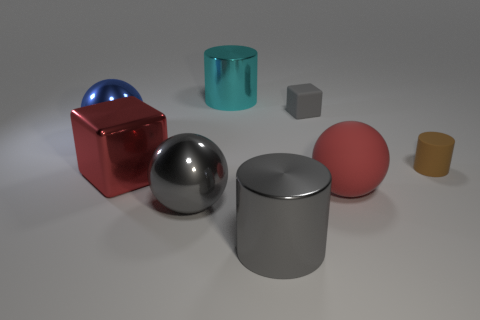There is a object that is the same color as the metal cube; what material is it?
Provide a succinct answer. Rubber. Is the number of big yellow matte balls less than the number of red shiny objects?
Your answer should be very brief. Yes. What number of other objects are there of the same color as the rubber block?
Provide a succinct answer. 2. Are the ball that is to the right of the big cyan cylinder and the large cyan cylinder made of the same material?
Your answer should be very brief. No. What material is the block that is left of the large cyan cylinder?
Your answer should be compact. Metal. There is a shiny sphere in front of the red rubber object to the right of the cyan shiny cylinder; how big is it?
Give a very brief answer. Large. Are there any cyan cylinders that have the same material as the big red block?
Provide a succinct answer. Yes. There is a gray shiny thing that is on the right side of the gray shiny ball that is left of the block behind the big red block; what shape is it?
Ensure brevity in your answer.  Cylinder. Do the sphere that is behind the large red metal cube and the tiny matte thing in front of the big blue shiny thing have the same color?
Offer a very short reply. No. Are there any other things that are the same size as the red matte ball?
Offer a very short reply. Yes. 